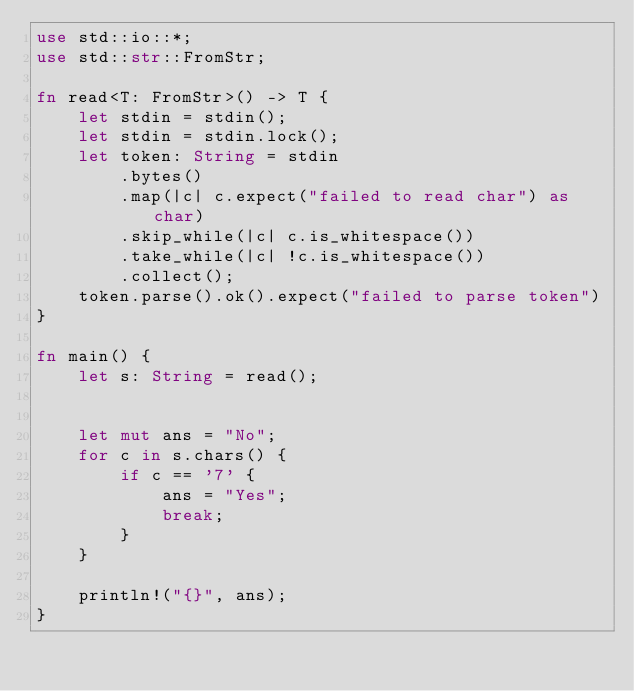Convert code to text. <code><loc_0><loc_0><loc_500><loc_500><_Rust_>use std::io::*;
use std::str::FromStr;

fn read<T: FromStr>() -> T {
    let stdin = stdin();
    let stdin = stdin.lock();
    let token: String = stdin
        .bytes()
        .map(|c| c.expect("failed to read char") as char) 
        .skip_while(|c| c.is_whitespace())
        .take_while(|c| !c.is_whitespace())
        .collect();
    token.parse().ok().expect("failed to parse token")
}

fn main() {
    let s: String = read();
    

    let mut ans = "No";
    for c in s.chars() {
        if c == '7' {
            ans = "Yes";
            break;
        }
    }

    println!("{}", ans);
}
</code> 